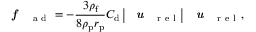Convert formula to latex. <formula><loc_0><loc_0><loc_500><loc_500>f _ { a d } = - \frac { 3 \rho _ { f } } { 8 \rho _ { p } r _ { p } } C _ { d } \left | u _ { r e l } \right | u _ { r e l } ,</formula> 